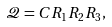<formula> <loc_0><loc_0><loc_500><loc_500>\mathcal { Q } = C R _ { 1 } R _ { 2 } R _ { 3 } ,</formula> 